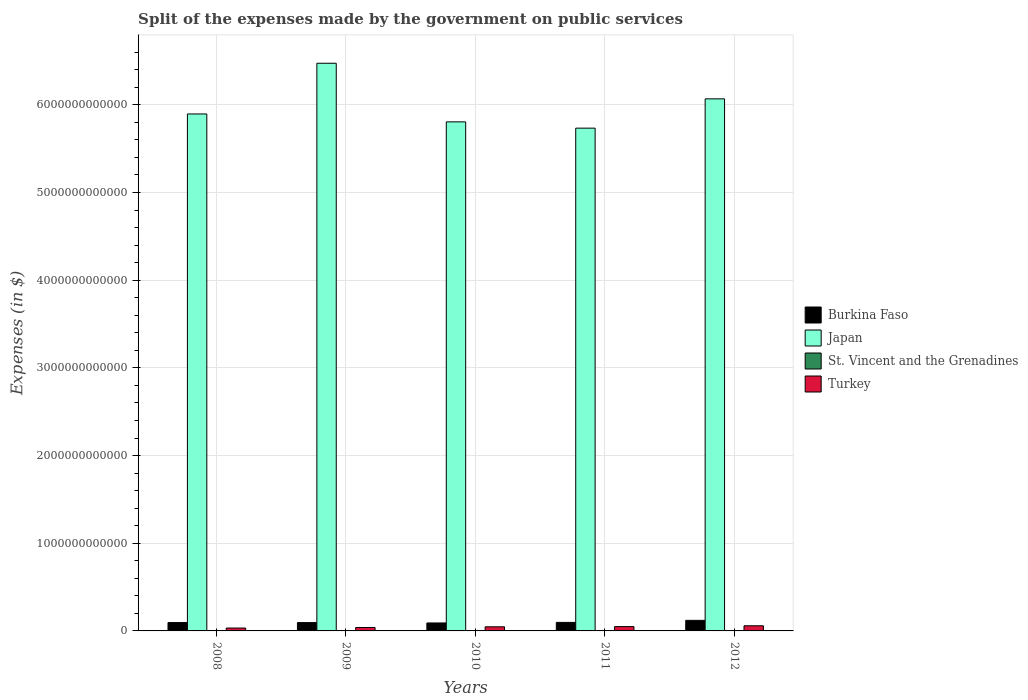Are the number of bars per tick equal to the number of legend labels?
Offer a very short reply. Yes. In how many cases, is the number of bars for a given year not equal to the number of legend labels?
Provide a short and direct response. 0. What is the expenses made by the government on public services in Burkina Faso in 2008?
Give a very brief answer. 9.53e+1. Across all years, what is the maximum expenses made by the government on public services in Burkina Faso?
Your answer should be very brief. 1.21e+11. Across all years, what is the minimum expenses made by the government on public services in Turkey?
Your answer should be compact. 3.28e+1. In which year was the expenses made by the government on public services in St. Vincent and the Grenadines maximum?
Your answer should be compact. 2008. In which year was the expenses made by the government on public services in Burkina Faso minimum?
Provide a short and direct response. 2010. What is the total expenses made by the government on public services in St. Vincent and the Grenadines in the graph?
Provide a short and direct response. 3.89e+08. What is the difference between the expenses made by the government on public services in St. Vincent and the Grenadines in 2009 and that in 2010?
Keep it short and to the point. 1.90e+07. What is the difference between the expenses made by the government on public services in Japan in 2010 and the expenses made by the government on public services in Burkina Faso in 2009?
Give a very brief answer. 5.71e+12. What is the average expenses made by the government on public services in Japan per year?
Your answer should be compact. 6.00e+12. In the year 2010, what is the difference between the expenses made by the government on public services in Japan and expenses made by the government on public services in St. Vincent and the Grenadines?
Offer a very short reply. 5.81e+12. In how many years, is the expenses made by the government on public services in Burkina Faso greater than 2600000000000 $?
Offer a terse response. 0. What is the ratio of the expenses made by the government on public services in Burkina Faso in 2011 to that in 2012?
Offer a very short reply. 0.81. Is the expenses made by the government on public services in St. Vincent and the Grenadines in 2008 less than that in 2012?
Give a very brief answer. No. Is the difference between the expenses made by the government on public services in Japan in 2011 and 2012 greater than the difference between the expenses made by the government on public services in St. Vincent and the Grenadines in 2011 and 2012?
Your response must be concise. No. What is the difference between the highest and the second highest expenses made by the government on public services in St. Vincent and the Grenadines?
Keep it short and to the point. 4.90e+06. What is the difference between the highest and the lowest expenses made by the government on public services in Turkey?
Ensure brevity in your answer.  2.58e+1. In how many years, is the expenses made by the government on public services in Burkina Faso greater than the average expenses made by the government on public services in Burkina Faso taken over all years?
Ensure brevity in your answer.  1. Is the sum of the expenses made by the government on public services in Burkina Faso in 2009 and 2010 greater than the maximum expenses made by the government on public services in Turkey across all years?
Make the answer very short. Yes. What does the 4th bar from the right in 2011 represents?
Your response must be concise. Burkina Faso. Is it the case that in every year, the sum of the expenses made by the government on public services in Burkina Faso and expenses made by the government on public services in St. Vincent and the Grenadines is greater than the expenses made by the government on public services in Turkey?
Your answer should be compact. Yes. How many bars are there?
Provide a succinct answer. 20. Are all the bars in the graph horizontal?
Keep it short and to the point. No. How many years are there in the graph?
Ensure brevity in your answer.  5. What is the difference between two consecutive major ticks on the Y-axis?
Offer a very short reply. 1.00e+12. Are the values on the major ticks of Y-axis written in scientific E-notation?
Offer a terse response. No. Does the graph contain any zero values?
Your answer should be compact. No. How are the legend labels stacked?
Provide a short and direct response. Vertical. What is the title of the graph?
Your response must be concise. Split of the expenses made by the government on public services. What is the label or title of the X-axis?
Provide a succinct answer. Years. What is the label or title of the Y-axis?
Offer a terse response. Expenses (in $). What is the Expenses (in $) of Burkina Faso in 2008?
Provide a short and direct response. 9.53e+1. What is the Expenses (in $) in Japan in 2008?
Keep it short and to the point. 5.90e+12. What is the Expenses (in $) in St. Vincent and the Grenadines in 2008?
Your answer should be very brief. 9.10e+07. What is the Expenses (in $) in Turkey in 2008?
Offer a terse response. 3.28e+1. What is the Expenses (in $) in Burkina Faso in 2009?
Ensure brevity in your answer.  9.51e+1. What is the Expenses (in $) in Japan in 2009?
Provide a short and direct response. 6.47e+12. What is the Expenses (in $) of St. Vincent and the Grenadines in 2009?
Offer a very short reply. 8.61e+07. What is the Expenses (in $) in Turkey in 2009?
Your answer should be compact. 3.91e+1. What is the Expenses (in $) in Burkina Faso in 2010?
Keep it short and to the point. 9.08e+1. What is the Expenses (in $) in Japan in 2010?
Your response must be concise. 5.81e+12. What is the Expenses (in $) of St. Vincent and the Grenadines in 2010?
Give a very brief answer. 6.71e+07. What is the Expenses (in $) of Turkey in 2010?
Your answer should be compact. 4.70e+1. What is the Expenses (in $) in Burkina Faso in 2011?
Your answer should be very brief. 9.71e+1. What is the Expenses (in $) of Japan in 2011?
Ensure brevity in your answer.  5.73e+12. What is the Expenses (in $) in St. Vincent and the Grenadines in 2011?
Give a very brief answer. 7.43e+07. What is the Expenses (in $) of Turkey in 2011?
Provide a short and direct response. 4.95e+1. What is the Expenses (in $) of Burkina Faso in 2012?
Offer a terse response. 1.21e+11. What is the Expenses (in $) of Japan in 2012?
Keep it short and to the point. 6.07e+12. What is the Expenses (in $) of St. Vincent and the Grenadines in 2012?
Make the answer very short. 7.05e+07. What is the Expenses (in $) of Turkey in 2012?
Your response must be concise. 5.86e+1. Across all years, what is the maximum Expenses (in $) in Burkina Faso?
Keep it short and to the point. 1.21e+11. Across all years, what is the maximum Expenses (in $) of Japan?
Your answer should be compact. 6.47e+12. Across all years, what is the maximum Expenses (in $) of St. Vincent and the Grenadines?
Your answer should be compact. 9.10e+07. Across all years, what is the maximum Expenses (in $) of Turkey?
Ensure brevity in your answer.  5.86e+1. Across all years, what is the minimum Expenses (in $) of Burkina Faso?
Offer a very short reply. 9.08e+1. Across all years, what is the minimum Expenses (in $) in Japan?
Offer a very short reply. 5.73e+12. Across all years, what is the minimum Expenses (in $) in St. Vincent and the Grenadines?
Offer a very short reply. 6.71e+07. Across all years, what is the minimum Expenses (in $) in Turkey?
Offer a terse response. 3.28e+1. What is the total Expenses (in $) of Burkina Faso in the graph?
Ensure brevity in your answer.  4.99e+11. What is the total Expenses (in $) of Japan in the graph?
Give a very brief answer. 3.00e+13. What is the total Expenses (in $) of St. Vincent and the Grenadines in the graph?
Ensure brevity in your answer.  3.89e+08. What is the total Expenses (in $) in Turkey in the graph?
Provide a short and direct response. 2.27e+11. What is the difference between the Expenses (in $) of Burkina Faso in 2008 and that in 2009?
Ensure brevity in your answer.  1.89e+08. What is the difference between the Expenses (in $) of Japan in 2008 and that in 2009?
Your response must be concise. -5.78e+11. What is the difference between the Expenses (in $) in St. Vincent and the Grenadines in 2008 and that in 2009?
Your response must be concise. 4.90e+06. What is the difference between the Expenses (in $) of Turkey in 2008 and that in 2009?
Keep it short and to the point. -6.22e+09. What is the difference between the Expenses (in $) of Burkina Faso in 2008 and that in 2010?
Provide a succinct answer. 4.54e+09. What is the difference between the Expenses (in $) in Japan in 2008 and that in 2010?
Your response must be concise. 9.02e+1. What is the difference between the Expenses (in $) of St. Vincent and the Grenadines in 2008 and that in 2010?
Provide a succinct answer. 2.39e+07. What is the difference between the Expenses (in $) in Turkey in 2008 and that in 2010?
Give a very brief answer. -1.42e+1. What is the difference between the Expenses (in $) in Burkina Faso in 2008 and that in 2011?
Give a very brief answer. -1.84e+09. What is the difference between the Expenses (in $) in Japan in 2008 and that in 2011?
Offer a very short reply. 1.62e+11. What is the difference between the Expenses (in $) of St. Vincent and the Grenadines in 2008 and that in 2011?
Make the answer very short. 1.67e+07. What is the difference between the Expenses (in $) in Turkey in 2008 and that in 2011?
Provide a succinct answer. -1.67e+1. What is the difference between the Expenses (in $) of Burkina Faso in 2008 and that in 2012?
Your response must be concise. -2.53e+1. What is the difference between the Expenses (in $) in Japan in 2008 and that in 2012?
Ensure brevity in your answer.  -1.72e+11. What is the difference between the Expenses (in $) of St. Vincent and the Grenadines in 2008 and that in 2012?
Provide a succinct answer. 2.05e+07. What is the difference between the Expenses (in $) of Turkey in 2008 and that in 2012?
Give a very brief answer. -2.58e+1. What is the difference between the Expenses (in $) in Burkina Faso in 2009 and that in 2010?
Provide a short and direct response. 4.36e+09. What is the difference between the Expenses (in $) in Japan in 2009 and that in 2010?
Keep it short and to the point. 6.68e+11. What is the difference between the Expenses (in $) in St. Vincent and the Grenadines in 2009 and that in 2010?
Give a very brief answer. 1.90e+07. What is the difference between the Expenses (in $) in Turkey in 2009 and that in 2010?
Offer a terse response. -7.96e+09. What is the difference between the Expenses (in $) of Burkina Faso in 2009 and that in 2011?
Give a very brief answer. -2.02e+09. What is the difference between the Expenses (in $) of Japan in 2009 and that in 2011?
Ensure brevity in your answer.  7.40e+11. What is the difference between the Expenses (in $) of St. Vincent and the Grenadines in 2009 and that in 2011?
Keep it short and to the point. 1.18e+07. What is the difference between the Expenses (in $) of Turkey in 2009 and that in 2011?
Offer a terse response. -1.05e+1. What is the difference between the Expenses (in $) of Burkina Faso in 2009 and that in 2012?
Offer a very short reply. -2.55e+1. What is the difference between the Expenses (in $) in Japan in 2009 and that in 2012?
Your response must be concise. 4.06e+11. What is the difference between the Expenses (in $) of St. Vincent and the Grenadines in 2009 and that in 2012?
Keep it short and to the point. 1.56e+07. What is the difference between the Expenses (in $) of Turkey in 2009 and that in 2012?
Give a very brief answer. -1.96e+1. What is the difference between the Expenses (in $) in Burkina Faso in 2010 and that in 2011?
Your response must be concise. -6.38e+09. What is the difference between the Expenses (in $) in Japan in 2010 and that in 2011?
Keep it short and to the point. 7.17e+1. What is the difference between the Expenses (in $) in St. Vincent and the Grenadines in 2010 and that in 2011?
Your response must be concise. -7.20e+06. What is the difference between the Expenses (in $) in Turkey in 2010 and that in 2011?
Your response must be concise. -2.49e+09. What is the difference between the Expenses (in $) in Burkina Faso in 2010 and that in 2012?
Offer a terse response. -2.98e+1. What is the difference between the Expenses (in $) in Japan in 2010 and that in 2012?
Provide a short and direct response. -2.62e+11. What is the difference between the Expenses (in $) in St. Vincent and the Grenadines in 2010 and that in 2012?
Ensure brevity in your answer.  -3.40e+06. What is the difference between the Expenses (in $) of Turkey in 2010 and that in 2012?
Ensure brevity in your answer.  -1.16e+1. What is the difference between the Expenses (in $) in Burkina Faso in 2011 and that in 2012?
Provide a succinct answer. -2.34e+1. What is the difference between the Expenses (in $) in Japan in 2011 and that in 2012?
Offer a very short reply. -3.34e+11. What is the difference between the Expenses (in $) of St. Vincent and the Grenadines in 2011 and that in 2012?
Make the answer very short. 3.80e+06. What is the difference between the Expenses (in $) in Turkey in 2011 and that in 2012?
Ensure brevity in your answer.  -9.12e+09. What is the difference between the Expenses (in $) in Burkina Faso in 2008 and the Expenses (in $) in Japan in 2009?
Your response must be concise. -6.38e+12. What is the difference between the Expenses (in $) in Burkina Faso in 2008 and the Expenses (in $) in St. Vincent and the Grenadines in 2009?
Offer a very short reply. 9.52e+1. What is the difference between the Expenses (in $) of Burkina Faso in 2008 and the Expenses (in $) of Turkey in 2009?
Your answer should be very brief. 5.62e+1. What is the difference between the Expenses (in $) of Japan in 2008 and the Expenses (in $) of St. Vincent and the Grenadines in 2009?
Make the answer very short. 5.90e+12. What is the difference between the Expenses (in $) of Japan in 2008 and the Expenses (in $) of Turkey in 2009?
Give a very brief answer. 5.86e+12. What is the difference between the Expenses (in $) in St. Vincent and the Grenadines in 2008 and the Expenses (in $) in Turkey in 2009?
Offer a terse response. -3.90e+1. What is the difference between the Expenses (in $) of Burkina Faso in 2008 and the Expenses (in $) of Japan in 2010?
Offer a terse response. -5.71e+12. What is the difference between the Expenses (in $) in Burkina Faso in 2008 and the Expenses (in $) in St. Vincent and the Grenadines in 2010?
Provide a succinct answer. 9.52e+1. What is the difference between the Expenses (in $) of Burkina Faso in 2008 and the Expenses (in $) of Turkey in 2010?
Make the answer very short. 4.83e+1. What is the difference between the Expenses (in $) in Japan in 2008 and the Expenses (in $) in St. Vincent and the Grenadines in 2010?
Give a very brief answer. 5.90e+12. What is the difference between the Expenses (in $) of Japan in 2008 and the Expenses (in $) of Turkey in 2010?
Ensure brevity in your answer.  5.85e+12. What is the difference between the Expenses (in $) of St. Vincent and the Grenadines in 2008 and the Expenses (in $) of Turkey in 2010?
Ensure brevity in your answer.  -4.69e+1. What is the difference between the Expenses (in $) of Burkina Faso in 2008 and the Expenses (in $) of Japan in 2011?
Offer a terse response. -5.64e+12. What is the difference between the Expenses (in $) in Burkina Faso in 2008 and the Expenses (in $) in St. Vincent and the Grenadines in 2011?
Provide a short and direct response. 9.52e+1. What is the difference between the Expenses (in $) in Burkina Faso in 2008 and the Expenses (in $) in Turkey in 2011?
Offer a very short reply. 4.58e+1. What is the difference between the Expenses (in $) of Japan in 2008 and the Expenses (in $) of St. Vincent and the Grenadines in 2011?
Your answer should be very brief. 5.90e+12. What is the difference between the Expenses (in $) in Japan in 2008 and the Expenses (in $) in Turkey in 2011?
Your answer should be compact. 5.85e+12. What is the difference between the Expenses (in $) of St. Vincent and the Grenadines in 2008 and the Expenses (in $) of Turkey in 2011?
Your answer should be very brief. -4.94e+1. What is the difference between the Expenses (in $) in Burkina Faso in 2008 and the Expenses (in $) in Japan in 2012?
Ensure brevity in your answer.  -5.97e+12. What is the difference between the Expenses (in $) of Burkina Faso in 2008 and the Expenses (in $) of St. Vincent and the Grenadines in 2012?
Ensure brevity in your answer.  9.52e+1. What is the difference between the Expenses (in $) in Burkina Faso in 2008 and the Expenses (in $) in Turkey in 2012?
Your response must be concise. 3.67e+1. What is the difference between the Expenses (in $) in Japan in 2008 and the Expenses (in $) in St. Vincent and the Grenadines in 2012?
Ensure brevity in your answer.  5.90e+12. What is the difference between the Expenses (in $) in Japan in 2008 and the Expenses (in $) in Turkey in 2012?
Offer a very short reply. 5.84e+12. What is the difference between the Expenses (in $) of St. Vincent and the Grenadines in 2008 and the Expenses (in $) of Turkey in 2012?
Provide a succinct answer. -5.85e+1. What is the difference between the Expenses (in $) in Burkina Faso in 2009 and the Expenses (in $) in Japan in 2010?
Offer a terse response. -5.71e+12. What is the difference between the Expenses (in $) in Burkina Faso in 2009 and the Expenses (in $) in St. Vincent and the Grenadines in 2010?
Your response must be concise. 9.51e+1. What is the difference between the Expenses (in $) of Burkina Faso in 2009 and the Expenses (in $) of Turkey in 2010?
Your response must be concise. 4.81e+1. What is the difference between the Expenses (in $) in Japan in 2009 and the Expenses (in $) in St. Vincent and the Grenadines in 2010?
Provide a short and direct response. 6.47e+12. What is the difference between the Expenses (in $) in Japan in 2009 and the Expenses (in $) in Turkey in 2010?
Offer a very short reply. 6.43e+12. What is the difference between the Expenses (in $) of St. Vincent and the Grenadines in 2009 and the Expenses (in $) of Turkey in 2010?
Offer a very short reply. -4.69e+1. What is the difference between the Expenses (in $) in Burkina Faso in 2009 and the Expenses (in $) in Japan in 2011?
Offer a very short reply. -5.64e+12. What is the difference between the Expenses (in $) of Burkina Faso in 2009 and the Expenses (in $) of St. Vincent and the Grenadines in 2011?
Make the answer very short. 9.50e+1. What is the difference between the Expenses (in $) of Burkina Faso in 2009 and the Expenses (in $) of Turkey in 2011?
Ensure brevity in your answer.  4.56e+1. What is the difference between the Expenses (in $) in Japan in 2009 and the Expenses (in $) in St. Vincent and the Grenadines in 2011?
Ensure brevity in your answer.  6.47e+12. What is the difference between the Expenses (in $) in Japan in 2009 and the Expenses (in $) in Turkey in 2011?
Provide a short and direct response. 6.42e+12. What is the difference between the Expenses (in $) of St. Vincent and the Grenadines in 2009 and the Expenses (in $) of Turkey in 2011?
Your answer should be compact. -4.94e+1. What is the difference between the Expenses (in $) in Burkina Faso in 2009 and the Expenses (in $) in Japan in 2012?
Make the answer very short. -5.97e+12. What is the difference between the Expenses (in $) in Burkina Faso in 2009 and the Expenses (in $) in St. Vincent and the Grenadines in 2012?
Offer a very short reply. 9.50e+1. What is the difference between the Expenses (in $) in Burkina Faso in 2009 and the Expenses (in $) in Turkey in 2012?
Offer a terse response. 3.65e+1. What is the difference between the Expenses (in $) in Japan in 2009 and the Expenses (in $) in St. Vincent and the Grenadines in 2012?
Give a very brief answer. 6.47e+12. What is the difference between the Expenses (in $) in Japan in 2009 and the Expenses (in $) in Turkey in 2012?
Give a very brief answer. 6.42e+12. What is the difference between the Expenses (in $) of St. Vincent and the Grenadines in 2009 and the Expenses (in $) of Turkey in 2012?
Make the answer very short. -5.85e+1. What is the difference between the Expenses (in $) in Burkina Faso in 2010 and the Expenses (in $) in Japan in 2011?
Offer a terse response. -5.64e+12. What is the difference between the Expenses (in $) in Burkina Faso in 2010 and the Expenses (in $) in St. Vincent and the Grenadines in 2011?
Keep it short and to the point. 9.07e+1. What is the difference between the Expenses (in $) in Burkina Faso in 2010 and the Expenses (in $) in Turkey in 2011?
Your answer should be compact. 4.13e+1. What is the difference between the Expenses (in $) in Japan in 2010 and the Expenses (in $) in St. Vincent and the Grenadines in 2011?
Keep it short and to the point. 5.81e+12. What is the difference between the Expenses (in $) in Japan in 2010 and the Expenses (in $) in Turkey in 2011?
Your response must be concise. 5.76e+12. What is the difference between the Expenses (in $) of St. Vincent and the Grenadines in 2010 and the Expenses (in $) of Turkey in 2011?
Offer a terse response. -4.94e+1. What is the difference between the Expenses (in $) in Burkina Faso in 2010 and the Expenses (in $) in Japan in 2012?
Make the answer very short. -5.98e+12. What is the difference between the Expenses (in $) in Burkina Faso in 2010 and the Expenses (in $) in St. Vincent and the Grenadines in 2012?
Your response must be concise. 9.07e+1. What is the difference between the Expenses (in $) in Burkina Faso in 2010 and the Expenses (in $) in Turkey in 2012?
Make the answer very short. 3.21e+1. What is the difference between the Expenses (in $) of Japan in 2010 and the Expenses (in $) of St. Vincent and the Grenadines in 2012?
Provide a succinct answer. 5.81e+12. What is the difference between the Expenses (in $) of Japan in 2010 and the Expenses (in $) of Turkey in 2012?
Your answer should be compact. 5.75e+12. What is the difference between the Expenses (in $) of St. Vincent and the Grenadines in 2010 and the Expenses (in $) of Turkey in 2012?
Your answer should be compact. -5.86e+1. What is the difference between the Expenses (in $) of Burkina Faso in 2011 and the Expenses (in $) of Japan in 2012?
Provide a short and direct response. -5.97e+12. What is the difference between the Expenses (in $) in Burkina Faso in 2011 and the Expenses (in $) in St. Vincent and the Grenadines in 2012?
Offer a very short reply. 9.71e+1. What is the difference between the Expenses (in $) of Burkina Faso in 2011 and the Expenses (in $) of Turkey in 2012?
Offer a very short reply. 3.85e+1. What is the difference between the Expenses (in $) of Japan in 2011 and the Expenses (in $) of St. Vincent and the Grenadines in 2012?
Provide a short and direct response. 5.73e+12. What is the difference between the Expenses (in $) in Japan in 2011 and the Expenses (in $) in Turkey in 2012?
Make the answer very short. 5.68e+12. What is the difference between the Expenses (in $) of St. Vincent and the Grenadines in 2011 and the Expenses (in $) of Turkey in 2012?
Give a very brief answer. -5.86e+1. What is the average Expenses (in $) of Burkina Faso per year?
Offer a terse response. 9.98e+1. What is the average Expenses (in $) of Japan per year?
Offer a very short reply. 6.00e+12. What is the average Expenses (in $) in St. Vincent and the Grenadines per year?
Provide a short and direct response. 7.78e+07. What is the average Expenses (in $) in Turkey per year?
Your response must be concise. 4.54e+1. In the year 2008, what is the difference between the Expenses (in $) of Burkina Faso and Expenses (in $) of Japan?
Provide a succinct answer. -5.80e+12. In the year 2008, what is the difference between the Expenses (in $) of Burkina Faso and Expenses (in $) of St. Vincent and the Grenadines?
Provide a short and direct response. 9.52e+1. In the year 2008, what is the difference between the Expenses (in $) in Burkina Faso and Expenses (in $) in Turkey?
Your response must be concise. 6.25e+1. In the year 2008, what is the difference between the Expenses (in $) in Japan and Expenses (in $) in St. Vincent and the Grenadines?
Your response must be concise. 5.90e+12. In the year 2008, what is the difference between the Expenses (in $) of Japan and Expenses (in $) of Turkey?
Ensure brevity in your answer.  5.86e+12. In the year 2008, what is the difference between the Expenses (in $) in St. Vincent and the Grenadines and Expenses (in $) in Turkey?
Offer a very short reply. -3.28e+1. In the year 2009, what is the difference between the Expenses (in $) of Burkina Faso and Expenses (in $) of Japan?
Provide a succinct answer. -6.38e+12. In the year 2009, what is the difference between the Expenses (in $) in Burkina Faso and Expenses (in $) in St. Vincent and the Grenadines?
Offer a terse response. 9.50e+1. In the year 2009, what is the difference between the Expenses (in $) in Burkina Faso and Expenses (in $) in Turkey?
Offer a terse response. 5.61e+1. In the year 2009, what is the difference between the Expenses (in $) of Japan and Expenses (in $) of St. Vincent and the Grenadines?
Your response must be concise. 6.47e+12. In the year 2009, what is the difference between the Expenses (in $) of Japan and Expenses (in $) of Turkey?
Make the answer very short. 6.44e+12. In the year 2009, what is the difference between the Expenses (in $) in St. Vincent and the Grenadines and Expenses (in $) in Turkey?
Offer a terse response. -3.90e+1. In the year 2010, what is the difference between the Expenses (in $) in Burkina Faso and Expenses (in $) in Japan?
Your response must be concise. -5.71e+12. In the year 2010, what is the difference between the Expenses (in $) in Burkina Faso and Expenses (in $) in St. Vincent and the Grenadines?
Offer a very short reply. 9.07e+1. In the year 2010, what is the difference between the Expenses (in $) of Burkina Faso and Expenses (in $) of Turkey?
Your answer should be compact. 4.37e+1. In the year 2010, what is the difference between the Expenses (in $) in Japan and Expenses (in $) in St. Vincent and the Grenadines?
Your response must be concise. 5.81e+12. In the year 2010, what is the difference between the Expenses (in $) of Japan and Expenses (in $) of Turkey?
Make the answer very short. 5.76e+12. In the year 2010, what is the difference between the Expenses (in $) in St. Vincent and the Grenadines and Expenses (in $) in Turkey?
Offer a very short reply. -4.70e+1. In the year 2011, what is the difference between the Expenses (in $) of Burkina Faso and Expenses (in $) of Japan?
Make the answer very short. -5.64e+12. In the year 2011, what is the difference between the Expenses (in $) of Burkina Faso and Expenses (in $) of St. Vincent and the Grenadines?
Ensure brevity in your answer.  9.71e+1. In the year 2011, what is the difference between the Expenses (in $) of Burkina Faso and Expenses (in $) of Turkey?
Ensure brevity in your answer.  4.76e+1. In the year 2011, what is the difference between the Expenses (in $) in Japan and Expenses (in $) in St. Vincent and the Grenadines?
Ensure brevity in your answer.  5.73e+12. In the year 2011, what is the difference between the Expenses (in $) of Japan and Expenses (in $) of Turkey?
Ensure brevity in your answer.  5.68e+12. In the year 2011, what is the difference between the Expenses (in $) in St. Vincent and the Grenadines and Expenses (in $) in Turkey?
Keep it short and to the point. -4.94e+1. In the year 2012, what is the difference between the Expenses (in $) of Burkina Faso and Expenses (in $) of Japan?
Offer a terse response. -5.95e+12. In the year 2012, what is the difference between the Expenses (in $) of Burkina Faso and Expenses (in $) of St. Vincent and the Grenadines?
Give a very brief answer. 1.21e+11. In the year 2012, what is the difference between the Expenses (in $) of Burkina Faso and Expenses (in $) of Turkey?
Offer a terse response. 6.19e+1. In the year 2012, what is the difference between the Expenses (in $) in Japan and Expenses (in $) in St. Vincent and the Grenadines?
Your response must be concise. 6.07e+12. In the year 2012, what is the difference between the Expenses (in $) in Japan and Expenses (in $) in Turkey?
Offer a terse response. 6.01e+12. In the year 2012, what is the difference between the Expenses (in $) in St. Vincent and the Grenadines and Expenses (in $) in Turkey?
Give a very brief answer. -5.86e+1. What is the ratio of the Expenses (in $) in Japan in 2008 to that in 2009?
Provide a succinct answer. 0.91. What is the ratio of the Expenses (in $) of St. Vincent and the Grenadines in 2008 to that in 2009?
Offer a very short reply. 1.06. What is the ratio of the Expenses (in $) in Turkey in 2008 to that in 2009?
Make the answer very short. 0.84. What is the ratio of the Expenses (in $) in Burkina Faso in 2008 to that in 2010?
Provide a succinct answer. 1.05. What is the ratio of the Expenses (in $) in Japan in 2008 to that in 2010?
Your answer should be compact. 1.02. What is the ratio of the Expenses (in $) in St. Vincent and the Grenadines in 2008 to that in 2010?
Your answer should be very brief. 1.36. What is the ratio of the Expenses (in $) of Turkey in 2008 to that in 2010?
Offer a terse response. 0.7. What is the ratio of the Expenses (in $) in Burkina Faso in 2008 to that in 2011?
Your answer should be very brief. 0.98. What is the ratio of the Expenses (in $) in Japan in 2008 to that in 2011?
Offer a very short reply. 1.03. What is the ratio of the Expenses (in $) in St. Vincent and the Grenadines in 2008 to that in 2011?
Offer a very short reply. 1.22. What is the ratio of the Expenses (in $) of Turkey in 2008 to that in 2011?
Your response must be concise. 0.66. What is the ratio of the Expenses (in $) in Burkina Faso in 2008 to that in 2012?
Keep it short and to the point. 0.79. What is the ratio of the Expenses (in $) of Japan in 2008 to that in 2012?
Offer a terse response. 0.97. What is the ratio of the Expenses (in $) in St. Vincent and the Grenadines in 2008 to that in 2012?
Your response must be concise. 1.29. What is the ratio of the Expenses (in $) in Turkey in 2008 to that in 2012?
Provide a short and direct response. 0.56. What is the ratio of the Expenses (in $) in Burkina Faso in 2009 to that in 2010?
Provide a short and direct response. 1.05. What is the ratio of the Expenses (in $) of Japan in 2009 to that in 2010?
Provide a short and direct response. 1.12. What is the ratio of the Expenses (in $) of St. Vincent and the Grenadines in 2009 to that in 2010?
Offer a terse response. 1.28. What is the ratio of the Expenses (in $) in Turkey in 2009 to that in 2010?
Offer a terse response. 0.83. What is the ratio of the Expenses (in $) in Burkina Faso in 2009 to that in 2011?
Your answer should be compact. 0.98. What is the ratio of the Expenses (in $) in Japan in 2009 to that in 2011?
Ensure brevity in your answer.  1.13. What is the ratio of the Expenses (in $) in St. Vincent and the Grenadines in 2009 to that in 2011?
Your answer should be compact. 1.16. What is the ratio of the Expenses (in $) in Turkey in 2009 to that in 2011?
Keep it short and to the point. 0.79. What is the ratio of the Expenses (in $) in Burkina Faso in 2009 to that in 2012?
Your answer should be very brief. 0.79. What is the ratio of the Expenses (in $) of Japan in 2009 to that in 2012?
Offer a very short reply. 1.07. What is the ratio of the Expenses (in $) in St. Vincent and the Grenadines in 2009 to that in 2012?
Ensure brevity in your answer.  1.22. What is the ratio of the Expenses (in $) in Turkey in 2009 to that in 2012?
Offer a very short reply. 0.67. What is the ratio of the Expenses (in $) in Burkina Faso in 2010 to that in 2011?
Your answer should be very brief. 0.93. What is the ratio of the Expenses (in $) in Japan in 2010 to that in 2011?
Your answer should be compact. 1.01. What is the ratio of the Expenses (in $) in St. Vincent and the Grenadines in 2010 to that in 2011?
Provide a short and direct response. 0.9. What is the ratio of the Expenses (in $) of Turkey in 2010 to that in 2011?
Keep it short and to the point. 0.95. What is the ratio of the Expenses (in $) of Burkina Faso in 2010 to that in 2012?
Offer a terse response. 0.75. What is the ratio of the Expenses (in $) of Japan in 2010 to that in 2012?
Provide a succinct answer. 0.96. What is the ratio of the Expenses (in $) in St. Vincent and the Grenadines in 2010 to that in 2012?
Keep it short and to the point. 0.95. What is the ratio of the Expenses (in $) of Turkey in 2010 to that in 2012?
Your response must be concise. 0.8. What is the ratio of the Expenses (in $) in Burkina Faso in 2011 to that in 2012?
Provide a succinct answer. 0.81. What is the ratio of the Expenses (in $) of Japan in 2011 to that in 2012?
Provide a short and direct response. 0.94. What is the ratio of the Expenses (in $) in St. Vincent and the Grenadines in 2011 to that in 2012?
Provide a succinct answer. 1.05. What is the ratio of the Expenses (in $) of Turkey in 2011 to that in 2012?
Offer a terse response. 0.84. What is the difference between the highest and the second highest Expenses (in $) in Burkina Faso?
Give a very brief answer. 2.34e+1. What is the difference between the highest and the second highest Expenses (in $) in Japan?
Offer a very short reply. 4.06e+11. What is the difference between the highest and the second highest Expenses (in $) in St. Vincent and the Grenadines?
Make the answer very short. 4.90e+06. What is the difference between the highest and the second highest Expenses (in $) of Turkey?
Give a very brief answer. 9.12e+09. What is the difference between the highest and the lowest Expenses (in $) in Burkina Faso?
Offer a very short reply. 2.98e+1. What is the difference between the highest and the lowest Expenses (in $) of Japan?
Your response must be concise. 7.40e+11. What is the difference between the highest and the lowest Expenses (in $) in St. Vincent and the Grenadines?
Offer a terse response. 2.39e+07. What is the difference between the highest and the lowest Expenses (in $) in Turkey?
Your answer should be very brief. 2.58e+1. 